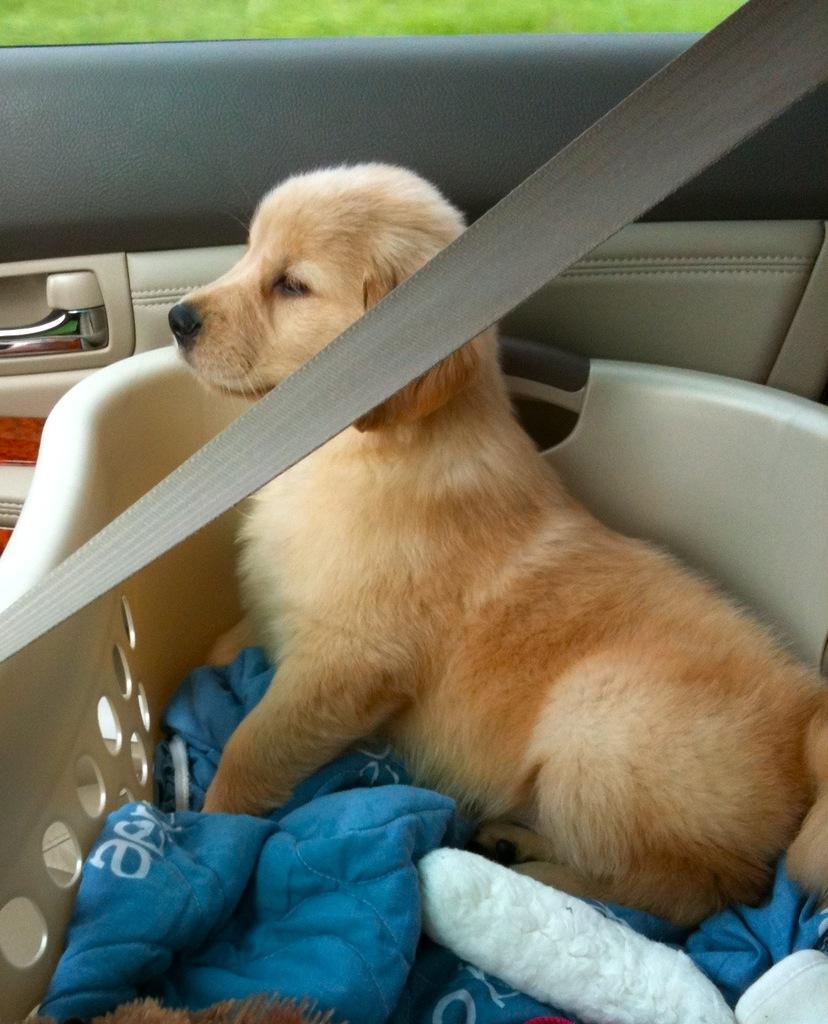How would you summarize this image in a sentence or two? Here in this picture we can see a dog present in a basket and we can also see a bed sheet beside it and we can say that it is kept in a car, as we can see a seat belt in front of it and behind that we can see a car door and a window present. 